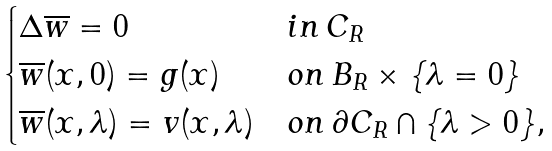<formula> <loc_0><loc_0><loc_500><loc_500>\begin{cases} \Delta \overline { w } = 0 & i n \, C _ { R } \\ \overline { w } ( x , 0 ) = g ( x ) & o n \, B _ { R } \times \{ \lambda = 0 \} \\ \overline { w } ( x , \lambda ) = v ( x , \lambda ) & o n \, \partial C _ { R } \cap \{ \lambda > 0 \} , \end{cases}</formula> 